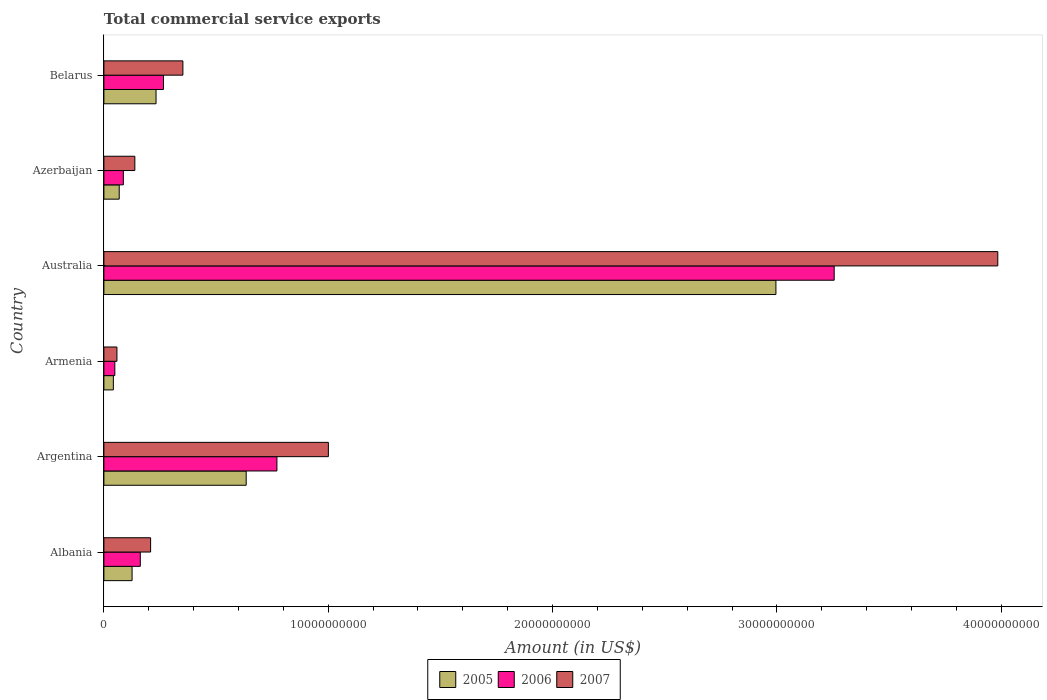How many different coloured bars are there?
Offer a very short reply. 3. How many groups of bars are there?
Keep it short and to the point. 6. Are the number of bars per tick equal to the number of legend labels?
Offer a terse response. Yes. Are the number of bars on each tick of the Y-axis equal?
Give a very brief answer. Yes. How many bars are there on the 3rd tick from the bottom?
Your response must be concise. 3. What is the label of the 4th group of bars from the top?
Give a very brief answer. Armenia. In how many cases, is the number of bars for a given country not equal to the number of legend labels?
Provide a succinct answer. 0. What is the total commercial service exports in 2007 in Armenia?
Provide a succinct answer. 5.82e+08. Across all countries, what is the maximum total commercial service exports in 2005?
Provide a short and direct response. 3.00e+1. Across all countries, what is the minimum total commercial service exports in 2006?
Make the answer very short. 4.87e+08. In which country was the total commercial service exports in 2007 minimum?
Offer a terse response. Armenia. What is the total total commercial service exports in 2005 in the graph?
Your response must be concise. 4.10e+1. What is the difference between the total commercial service exports in 2006 in Albania and that in Belarus?
Give a very brief answer. -1.03e+09. What is the difference between the total commercial service exports in 2006 in Belarus and the total commercial service exports in 2007 in Australia?
Your response must be concise. -3.72e+1. What is the average total commercial service exports in 2007 per country?
Provide a succinct answer. 9.57e+09. What is the difference between the total commercial service exports in 2007 and total commercial service exports in 2005 in Belarus?
Ensure brevity in your answer.  1.20e+09. In how many countries, is the total commercial service exports in 2005 greater than 22000000000 US$?
Ensure brevity in your answer.  1. What is the ratio of the total commercial service exports in 2006 in Albania to that in Armenia?
Your answer should be compact. 3.33. Is the total commercial service exports in 2007 in Armenia less than that in Azerbaijan?
Ensure brevity in your answer.  Yes. What is the difference between the highest and the second highest total commercial service exports in 2006?
Your answer should be very brief. 2.48e+1. What is the difference between the highest and the lowest total commercial service exports in 2007?
Provide a short and direct response. 3.93e+1. Is the sum of the total commercial service exports in 2005 in Australia and Belarus greater than the maximum total commercial service exports in 2006 across all countries?
Offer a terse response. No. What does the 3rd bar from the bottom in Albania represents?
Your answer should be compact. 2007. Is it the case that in every country, the sum of the total commercial service exports in 2005 and total commercial service exports in 2006 is greater than the total commercial service exports in 2007?
Keep it short and to the point. Yes. Are all the bars in the graph horizontal?
Keep it short and to the point. Yes. What is the difference between two consecutive major ticks on the X-axis?
Your answer should be compact. 1.00e+1. Are the values on the major ticks of X-axis written in scientific E-notation?
Keep it short and to the point. No. Does the graph contain any zero values?
Your answer should be very brief. No. Where does the legend appear in the graph?
Ensure brevity in your answer.  Bottom center. How many legend labels are there?
Give a very brief answer. 3. How are the legend labels stacked?
Your response must be concise. Horizontal. What is the title of the graph?
Offer a terse response. Total commercial service exports. What is the label or title of the Y-axis?
Give a very brief answer. Country. What is the Amount (in US$) of 2005 in Albania?
Your answer should be compact. 1.26e+09. What is the Amount (in US$) of 2006 in Albania?
Keep it short and to the point. 1.62e+09. What is the Amount (in US$) of 2007 in Albania?
Offer a terse response. 2.08e+09. What is the Amount (in US$) in 2005 in Argentina?
Your answer should be very brief. 6.34e+09. What is the Amount (in US$) of 2006 in Argentina?
Keep it short and to the point. 7.71e+09. What is the Amount (in US$) of 2007 in Argentina?
Provide a succinct answer. 1.00e+1. What is the Amount (in US$) in 2005 in Armenia?
Offer a terse response. 4.22e+08. What is the Amount (in US$) in 2006 in Armenia?
Make the answer very short. 4.87e+08. What is the Amount (in US$) of 2007 in Armenia?
Keep it short and to the point. 5.82e+08. What is the Amount (in US$) of 2005 in Australia?
Provide a succinct answer. 3.00e+1. What is the Amount (in US$) in 2006 in Australia?
Offer a terse response. 3.26e+1. What is the Amount (in US$) in 2007 in Australia?
Provide a short and direct response. 3.98e+1. What is the Amount (in US$) of 2005 in Azerbaijan?
Provide a short and direct response. 6.83e+08. What is the Amount (in US$) in 2006 in Azerbaijan?
Provide a succinct answer. 8.67e+08. What is the Amount (in US$) of 2007 in Azerbaijan?
Provide a short and direct response. 1.38e+09. What is the Amount (in US$) in 2005 in Belarus?
Offer a terse response. 2.32e+09. What is the Amount (in US$) of 2006 in Belarus?
Your response must be concise. 2.66e+09. What is the Amount (in US$) of 2007 in Belarus?
Provide a short and direct response. 3.52e+09. Across all countries, what is the maximum Amount (in US$) of 2005?
Your response must be concise. 3.00e+1. Across all countries, what is the maximum Amount (in US$) of 2006?
Your response must be concise. 3.26e+1. Across all countries, what is the maximum Amount (in US$) of 2007?
Keep it short and to the point. 3.98e+1. Across all countries, what is the minimum Amount (in US$) in 2005?
Keep it short and to the point. 4.22e+08. Across all countries, what is the minimum Amount (in US$) of 2006?
Offer a terse response. 4.87e+08. Across all countries, what is the minimum Amount (in US$) in 2007?
Make the answer very short. 5.82e+08. What is the total Amount (in US$) in 2005 in the graph?
Offer a terse response. 4.10e+1. What is the total Amount (in US$) in 2006 in the graph?
Provide a succinct answer. 4.59e+1. What is the total Amount (in US$) in 2007 in the graph?
Give a very brief answer. 5.74e+1. What is the difference between the Amount (in US$) in 2005 in Albania and that in Argentina?
Your answer should be very brief. -5.09e+09. What is the difference between the Amount (in US$) of 2006 in Albania and that in Argentina?
Provide a short and direct response. -6.09e+09. What is the difference between the Amount (in US$) in 2007 in Albania and that in Argentina?
Your answer should be compact. -7.92e+09. What is the difference between the Amount (in US$) in 2005 in Albania and that in Armenia?
Make the answer very short. 8.34e+08. What is the difference between the Amount (in US$) in 2006 in Albania and that in Armenia?
Make the answer very short. 1.14e+09. What is the difference between the Amount (in US$) in 2007 in Albania and that in Armenia?
Give a very brief answer. 1.50e+09. What is the difference between the Amount (in US$) of 2005 in Albania and that in Australia?
Your answer should be very brief. -2.87e+1. What is the difference between the Amount (in US$) of 2006 in Albania and that in Australia?
Give a very brief answer. -3.09e+1. What is the difference between the Amount (in US$) in 2007 in Albania and that in Australia?
Provide a short and direct response. -3.78e+1. What is the difference between the Amount (in US$) in 2005 in Albania and that in Azerbaijan?
Your response must be concise. 5.73e+08. What is the difference between the Amount (in US$) in 2006 in Albania and that in Azerbaijan?
Your answer should be compact. 7.56e+08. What is the difference between the Amount (in US$) in 2007 in Albania and that in Azerbaijan?
Keep it short and to the point. 7.03e+08. What is the difference between the Amount (in US$) in 2005 in Albania and that in Belarus?
Keep it short and to the point. -1.07e+09. What is the difference between the Amount (in US$) in 2006 in Albania and that in Belarus?
Offer a terse response. -1.03e+09. What is the difference between the Amount (in US$) in 2007 in Albania and that in Belarus?
Give a very brief answer. -1.44e+09. What is the difference between the Amount (in US$) of 2005 in Argentina and that in Armenia?
Ensure brevity in your answer.  5.92e+09. What is the difference between the Amount (in US$) of 2006 in Argentina and that in Armenia?
Offer a very short reply. 7.23e+09. What is the difference between the Amount (in US$) in 2007 in Argentina and that in Armenia?
Your response must be concise. 9.42e+09. What is the difference between the Amount (in US$) in 2005 in Argentina and that in Australia?
Ensure brevity in your answer.  -2.36e+1. What is the difference between the Amount (in US$) of 2006 in Argentina and that in Australia?
Offer a very short reply. -2.48e+1. What is the difference between the Amount (in US$) in 2007 in Argentina and that in Australia?
Your answer should be compact. -2.98e+1. What is the difference between the Amount (in US$) in 2005 in Argentina and that in Azerbaijan?
Your answer should be very brief. 5.66e+09. What is the difference between the Amount (in US$) in 2006 in Argentina and that in Azerbaijan?
Keep it short and to the point. 6.85e+09. What is the difference between the Amount (in US$) in 2007 in Argentina and that in Azerbaijan?
Make the answer very short. 8.63e+09. What is the difference between the Amount (in US$) in 2005 in Argentina and that in Belarus?
Provide a short and direct response. 4.02e+09. What is the difference between the Amount (in US$) in 2006 in Argentina and that in Belarus?
Give a very brief answer. 5.06e+09. What is the difference between the Amount (in US$) in 2007 in Argentina and that in Belarus?
Keep it short and to the point. 6.48e+09. What is the difference between the Amount (in US$) in 2005 in Armenia and that in Australia?
Give a very brief answer. -2.95e+1. What is the difference between the Amount (in US$) in 2006 in Armenia and that in Australia?
Keep it short and to the point. -3.21e+1. What is the difference between the Amount (in US$) of 2007 in Armenia and that in Australia?
Your answer should be compact. -3.93e+1. What is the difference between the Amount (in US$) in 2005 in Armenia and that in Azerbaijan?
Offer a terse response. -2.61e+08. What is the difference between the Amount (in US$) of 2006 in Armenia and that in Azerbaijan?
Your response must be concise. -3.79e+08. What is the difference between the Amount (in US$) in 2007 in Armenia and that in Azerbaijan?
Your response must be concise. -7.98e+08. What is the difference between the Amount (in US$) in 2005 in Armenia and that in Belarus?
Provide a succinct answer. -1.90e+09. What is the difference between the Amount (in US$) of 2006 in Armenia and that in Belarus?
Your answer should be compact. -2.17e+09. What is the difference between the Amount (in US$) in 2007 in Armenia and that in Belarus?
Offer a very short reply. -2.94e+09. What is the difference between the Amount (in US$) of 2005 in Australia and that in Azerbaijan?
Offer a very short reply. 2.93e+1. What is the difference between the Amount (in US$) of 2006 in Australia and that in Azerbaijan?
Your response must be concise. 3.17e+1. What is the difference between the Amount (in US$) of 2007 in Australia and that in Azerbaijan?
Provide a short and direct response. 3.85e+1. What is the difference between the Amount (in US$) in 2005 in Australia and that in Belarus?
Keep it short and to the point. 2.76e+1. What is the difference between the Amount (in US$) of 2006 in Australia and that in Belarus?
Give a very brief answer. 2.99e+1. What is the difference between the Amount (in US$) in 2007 in Australia and that in Belarus?
Give a very brief answer. 3.63e+1. What is the difference between the Amount (in US$) in 2005 in Azerbaijan and that in Belarus?
Give a very brief answer. -1.64e+09. What is the difference between the Amount (in US$) in 2006 in Azerbaijan and that in Belarus?
Provide a short and direct response. -1.79e+09. What is the difference between the Amount (in US$) in 2007 in Azerbaijan and that in Belarus?
Provide a short and direct response. -2.14e+09. What is the difference between the Amount (in US$) in 2005 in Albania and the Amount (in US$) in 2006 in Argentina?
Ensure brevity in your answer.  -6.46e+09. What is the difference between the Amount (in US$) of 2005 in Albania and the Amount (in US$) of 2007 in Argentina?
Give a very brief answer. -8.75e+09. What is the difference between the Amount (in US$) of 2006 in Albania and the Amount (in US$) of 2007 in Argentina?
Offer a very short reply. -8.38e+09. What is the difference between the Amount (in US$) of 2005 in Albania and the Amount (in US$) of 2006 in Armenia?
Make the answer very short. 7.69e+08. What is the difference between the Amount (in US$) of 2005 in Albania and the Amount (in US$) of 2007 in Armenia?
Offer a terse response. 6.75e+08. What is the difference between the Amount (in US$) of 2006 in Albania and the Amount (in US$) of 2007 in Armenia?
Ensure brevity in your answer.  1.04e+09. What is the difference between the Amount (in US$) of 2005 in Albania and the Amount (in US$) of 2006 in Australia?
Make the answer very short. -3.13e+1. What is the difference between the Amount (in US$) of 2005 in Albania and the Amount (in US$) of 2007 in Australia?
Your answer should be compact. -3.86e+1. What is the difference between the Amount (in US$) of 2006 in Albania and the Amount (in US$) of 2007 in Australia?
Ensure brevity in your answer.  -3.82e+1. What is the difference between the Amount (in US$) of 2005 in Albania and the Amount (in US$) of 2006 in Azerbaijan?
Ensure brevity in your answer.  3.89e+08. What is the difference between the Amount (in US$) of 2005 in Albania and the Amount (in US$) of 2007 in Azerbaijan?
Ensure brevity in your answer.  -1.24e+08. What is the difference between the Amount (in US$) in 2006 in Albania and the Amount (in US$) in 2007 in Azerbaijan?
Keep it short and to the point. 2.43e+08. What is the difference between the Amount (in US$) of 2005 in Albania and the Amount (in US$) of 2006 in Belarus?
Offer a terse response. -1.40e+09. What is the difference between the Amount (in US$) in 2005 in Albania and the Amount (in US$) in 2007 in Belarus?
Ensure brevity in your answer.  -2.27e+09. What is the difference between the Amount (in US$) of 2006 in Albania and the Amount (in US$) of 2007 in Belarus?
Your response must be concise. -1.90e+09. What is the difference between the Amount (in US$) in 2005 in Argentina and the Amount (in US$) in 2006 in Armenia?
Give a very brief answer. 5.86e+09. What is the difference between the Amount (in US$) in 2005 in Argentina and the Amount (in US$) in 2007 in Armenia?
Keep it short and to the point. 5.76e+09. What is the difference between the Amount (in US$) of 2006 in Argentina and the Amount (in US$) of 2007 in Armenia?
Your answer should be compact. 7.13e+09. What is the difference between the Amount (in US$) of 2005 in Argentina and the Amount (in US$) of 2006 in Australia?
Ensure brevity in your answer.  -2.62e+1. What is the difference between the Amount (in US$) in 2005 in Argentina and the Amount (in US$) in 2007 in Australia?
Keep it short and to the point. -3.35e+1. What is the difference between the Amount (in US$) of 2006 in Argentina and the Amount (in US$) of 2007 in Australia?
Make the answer very short. -3.21e+1. What is the difference between the Amount (in US$) in 2005 in Argentina and the Amount (in US$) in 2006 in Azerbaijan?
Your answer should be very brief. 5.48e+09. What is the difference between the Amount (in US$) of 2005 in Argentina and the Amount (in US$) of 2007 in Azerbaijan?
Your answer should be very brief. 4.96e+09. What is the difference between the Amount (in US$) of 2006 in Argentina and the Amount (in US$) of 2007 in Azerbaijan?
Provide a short and direct response. 6.33e+09. What is the difference between the Amount (in US$) of 2005 in Argentina and the Amount (in US$) of 2006 in Belarus?
Ensure brevity in your answer.  3.69e+09. What is the difference between the Amount (in US$) in 2005 in Argentina and the Amount (in US$) in 2007 in Belarus?
Your answer should be very brief. 2.82e+09. What is the difference between the Amount (in US$) of 2006 in Argentina and the Amount (in US$) of 2007 in Belarus?
Your answer should be very brief. 4.19e+09. What is the difference between the Amount (in US$) of 2005 in Armenia and the Amount (in US$) of 2006 in Australia?
Provide a short and direct response. -3.21e+1. What is the difference between the Amount (in US$) in 2005 in Armenia and the Amount (in US$) in 2007 in Australia?
Provide a succinct answer. -3.94e+1. What is the difference between the Amount (in US$) in 2006 in Armenia and the Amount (in US$) in 2007 in Australia?
Give a very brief answer. -3.94e+1. What is the difference between the Amount (in US$) of 2005 in Armenia and the Amount (in US$) of 2006 in Azerbaijan?
Provide a short and direct response. -4.45e+08. What is the difference between the Amount (in US$) in 2005 in Armenia and the Amount (in US$) in 2007 in Azerbaijan?
Provide a succinct answer. -9.58e+08. What is the difference between the Amount (in US$) of 2006 in Armenia and the Amount (in US$) of 2007 in Azerbaijan?
Your answer should be compact. -8.92e+08. What is the difference between the Amount (in US$) in 2005 in Armenia and the Amount (in US$) in 2006 in Belarus?
Ensure brevity in your answer.  -2.24e+09. What is the difference between the Amount (in US$) of 2005 in Armenia and the Amount (in US$) of 2007 in Belarus?
Give a very brief answer. -3.10e+09. What is the difference between the Amount (in US$) in 2006 in Armenia and the Amount (in US$) in 2007 in Belarus?
Your answer should be very brief. -3.03e+09. What is the difference between the Amount (in US$) of 2005 in Australia and the Amount (in US$) of 2006 in Azerbaijan?
Offer a terse response. 2.91e+1. What is the difference between the Amount (in US$) in 2005 in Australia and the Amount (in US$) in 2007 in Azerbaijan?
Your answer should be compact. 2.86e+1. What is the difference between the Amount (in US$) of 2006 in Australia and the Amount (in US$) of 2007 in Azerbaijan?
Offer a terse response. 3.12e+1. What is the difference between the Amount (in US$) of 2005 in Australia and the Amount (in US$) of 2006 in Belarus?
Give a very brief answer. 2.73e+1. What is the difference between the Amount (in US$) of 2005 in Australia and the Amount (in US$) of 2007 in Belarus?
Ensure brevity in your answer.  2.64e+1. What is the difference between the Amount (in US$) of 2006 in Australia and the Amount (in US$) of 2007 in Belarus?
Your response must be concise. 2.90e+1. What is the difference between the Amount (in US$) of 2005 in Azerbaijan and the Amount (in US$) of 2006 in Belarus?
Give a very brief answer. -1.97e+09. What is the difference between the Amount (in US$) of 2005 in Azerbaijan and the Amount (in US$) of 2007 in Belarus?
Ensure brevity in your answer.  -2.84e+09. What is the difference between the Amount (in US$) of 2006 in Azerbaijan and the Amount (in US$) of 2007 in Belarus?
Make the answer very short. -2.65e+09. What is the average Amount (in US$) in 2005 per country?
Give a very brief answer. 6.83e+09. What is the average Amount (in US$) of 2006 per country?
Your response must be concise. 7.65e+09. What is the average Amount (in US$) of 2007 per country?
Ensure brevity in your answer.  9.57e+09. What is the difference between the Amount (in US$) of 2005 and Amount (in US$) of 2006 in Albania?
Give a very brief answer. -3.67e+08. What is the difference between the Amount (in US$) of 2005 and Amount (in US$) of 2007 in Albania?
Give a very brief answer. -8.26e+08. What is the difference between the Amount (in US$) of 2006 and Amount (in US$) of 2007 in Albania?
Provide a short and direct response. -4.59e+08. What is the difference between the Amount (in US$) in 2005 and Amount (in US$) in 2006 in Argentina?
Your answer should be very brief. -1.37e+09. What is the difference between the Amount (in US$) of 2005 and Amount (in US$) of 2007 in Argentina?
Offer a very short reply. -3.66e+09. What is the difference between the Amount (in US$) of 2006 and Amount (in US$) of 2007 in Argentina?
Offer a very short reply. -2.29e+09. What is the difference between the Amount (in US$) of 2005 and Amount (in US$) of 2006 in Armenia?
Offer a very short reply. -6.57e+07. What is the difference between the Amount (in US$) of 2005 and Amount (in US$) of 2007 in Armenia?
Make the answer very short. -1.60e+08. What is the difference between the Amount (in US$) of 2006 and Amount (in US$) of 2007 in Armenia?
Make the answer very short. -9.43e+07. What is the difference between the Amount (in US$) of 2005 and Amount (in US$) of 2006 in Australia?
Offer a terse response. -2.60e+09. What is the difference between the Amount (in US$) in 2005 and Amount (in US$) in 2007 in Australia?
Your answer should be compact. -9.89e+09. What is the difference between the Amount (in US$) in 2006 and Amount (in US$) in 2007 in Australia?
Provide a short and direct response. -7.29e+09. What is the difference between the Amount (in US$) in 2005 and Amount (in US$) in 2006 in Azerbaijan?
Offer a terse response. -1.84e+08. What is the difference between the Amount (in US$) in 2005 and Amount (in US$) in 2007 in Azerbaijan?
Provide a succinct answer. -6.97e+08. What is the difference between the Amount (in US$) of 2006 and Amount (in US$) of 2007 in Azerbaijan?
Make the answer very short. -5.13e+08. What is the difference between the Amount (in US$) of 2005 and Amount (in US$) of 2006 in Belarus?
Your answer should be very brief. -3.32e+08. What is the difference between the Amount (in US$) of 2005 and Amount (in US$) of 2007 in Belarus?
Keep it short and to the point. -1.20e+09. What is the difference between the Amount (in US$) of 2006 and Amount (in US$) of 2007 in Belarus?
Give a very brief answer. -8.64e+08. What is the ratio of the Amount (in US$) in 2005 in Albania to that in Argentina?
Provide a succinct answer. 0.2. What is the ratio of the Amount (in US$) in 2006 in Albania to that in Argentina?
Ensure brevity in your answer.  0.21. What is the ratio of the Amount (in US$) in 2007 in Albania to that in Argentina?
Your answer should be compact. 0.21. What is the ratio of the Amount (in US$) of 2005 in Albania to that in Armenia?
Offer a very short reply. 2.98. What is the ratio of the Amount (in US$) of 2006 in Albania to that in Armenia?
Provide a succinct answer. 3.33. What is the ratio of the Amount (in US$) of 2007 in Albania to that in Armenia?
Make the answer very short. 3.58. What is the ratio of the Amount (in US$) in 2005 in Albania to that in Australia?
Give a very brief answer. 0.04. What is the ratio of the Amount (in US$) in 2006 in Albania to that in Australia?
Provide a short and direct response. 0.05. What is the ratio of the Amount (in US$) of 2007 in Albania to that in Australia?
Your answer should be compact. 0.05. What is the ratio of the Amount (in US$) in 2005 in Albania to that in Azerbaijan?
Your response must be concise. 1.84. What is the ratio of the Amount (in US$) in 2006 in Albania to that in Azerbaijan?
Provide a short and direct response. 1.87. What is the ratio of the Amount (in US$) in 2007 in Albania to that in Azerbaijan?
Your answer should be compact. 1.51. What is the ratio of the Amount (in US$) of 2005 in Albania to that in Belarus?
Your answer should be compact. 0.54. What is the ratio of the Amount (in US$) of 2006 in Albania to that in Belarus?
Keep it short and to the point. 0.61. What is the ratio of the Amount (in US$) in 2007 in Albania to that in Belarus?
Make the answer very short. 0.59. What is the ratio of the Amount (in US$) in 2005 in Argentina to that in Armenia?
Provide a short and direct response. 15.04. What is the ratio of the Amount (in US$) of 2006 in Argentina to that in Armenia?
Give a very brief answer. 15.82. What is the ratio of the Amount (in US$) of 2007 in Argentina to that in Armenia?
Your answer should be compact. 17.2. What is the ratio of the Amount (in US$) of 2005 in Argentina to that in Australia?
Offer a terse response. 0.21. What is the ratio of the Amount (in US$) of 2006 in Argentina to that in Australia?
Provide a short and direct response. 0.24. What is the ratio of the Amount (in US$) in 2007 in Argentina to that in Australia?
Your response must be concise. 0.25. What is the ratio of the Amount (in US$) in 2005 in Argentina to that in Azerbaijan?
Your answer should be very brief. 9.28. What is the ratio of the Amount (in US$) in 2006 in Argentina to that in Azerbaijan?
Make the answer very short. 8.9. What is the ratio of the Amount (in US$) in 2007 in Argentina to that in Azerbaijan?
Your answer should be compact. 7.25. What is the ratio of the Amount (in US$) of 2005 in Argentina to that in Belarus?
Offer a very short reply. 2.73. What is the ratio of the Amount (in US$) of 2006 in Argentina to that in Belarus?
Give a very brief answer. 2.9. What is the ratio of the Amount (in US$) in 2007 in Argentina to that in Belarus?
Offer a terse response. 2.84. What is the ratio of the Amount (in US$) of 2005 in Armenia to that in Australia?
Keep it short and to the point. 0.01. What is the ratio of the Amount (in US$) in 2006 in Armenia to that in Australia?
Offer a terse response. 0.01. What is the ratio of the Amount (in US$) of 2007 in Armenia to that in Australia?
Keep it short and to the point. 0.01. What is the ratio of the Amount (in US$) of 2005 in Armenia to that in Azerbaijan?
Your response must be concise. 0.62. What is the ratio of the Amount (in US$) of 2006 in Armenia to that in Azerbaijan?
Offer a very short reply. 0.56. What is the ratio of the Amount (in US$) of 2007 in Armenia to that in Azerbaijan?
Offer a very short reply. 0.42. What is the ratio of the Amount (in US$) of 2005 in Armenia to that in Belarus?
Give a very brief answer. 0.18. What is the ratio of the Amount (in US$) in 2006 in Armenia to that in Belarus?
Offer a terse response. 0.18. What is the ratio of the Amount (in US$) in 2007 in Armenia to that in Belarus?
Give a very brief answer. 0.17. What is the ratio of the Amount (in US$) of 2005 in Australia to that in Azerbaijan?
Your response must be concise. 43.85. What is the ratio of the Amount (in US$) in 2006 in Australia to that in Azerbaijan?
Your response must be concise. 37.55. What is the ratio of the Amount (in US$) of 2007 in Australia to that in Azerbaijan?
Give a very brief answer. 28.88. What is the ratio of the Amount (in US$) of 2005 in Australia to that in Belarus?
Ensure brevity in your answer.  12.89. What is the ratio of the Amount (in US$) of 2006 in Australia to that in Belarus?
Offer a terse response. 12.25. What is the ratio of the Amount (in US$) in 2007 in Australia to that in Belarus?
Make the answer very short. 11.31. What is the ratio of the Amount (in US$) in 2005 in Azerbaijan to that in Belarus?
Keep it short and to the point. 0.29. What is the ratio of the Amount (in US$) in 2006 in Azerbaijan to that in Belarus?
Provide a short and direct response. 0.33. What is the ratio of the Amount (in US$) of 2007 in Azerbaijan to that in Belarus?
Your response must be concise. 0.39. What is the difference between the highest and the second highest Amount (in US$) in 2005?
Keep it short and to the point. 2.36e+1. What is the difference between the highest and the second highest Amount (in US$) in 2006?
Keep it short and to the point. 2.48e+1. What is the difference between the highest and the second highest Amount (in US$) in 2007?
Keep it short and to the point. 2.98e+1. What is the difference between the highest and the lowest Amount (in US$) of 2005?
Give a very brief answer. 2.95e+1. What is the difference between the highest and the lowest Amount (in US$) in 2006?
Provide a succinct answer. 3.21e+1. What is the difference between the highest and the lowest Amount (in US$) in 2007?
Your answer should be compact. 3.93e+1. 